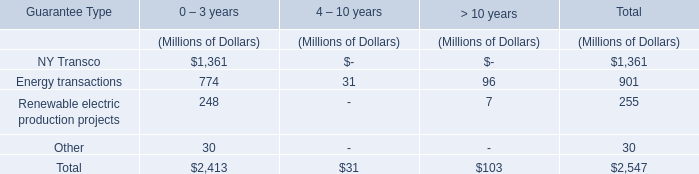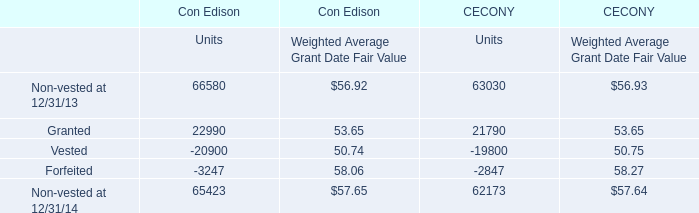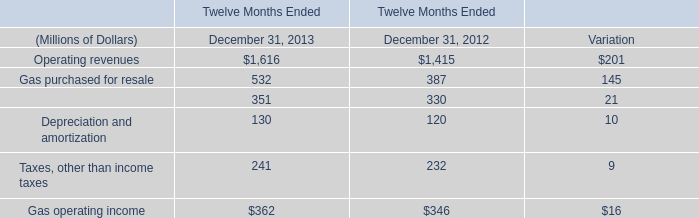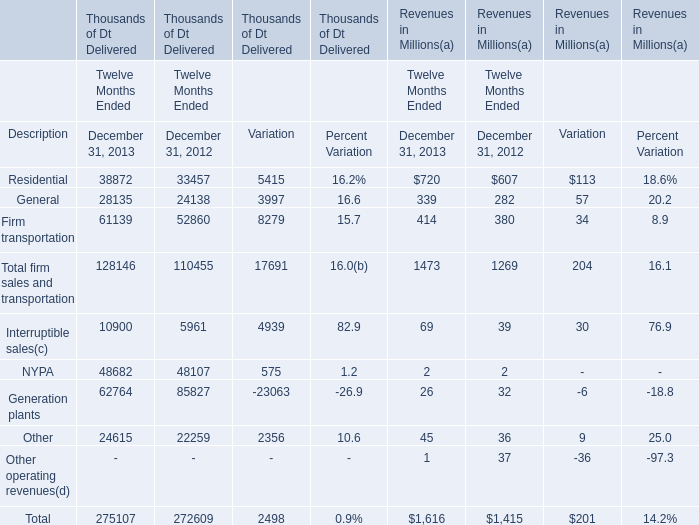In the year with lowest amount of Generation plants for Revenues, what's the increasing rate of General? 
Computations: ((339 - 282) / 282)
Answer: 0.20213. 